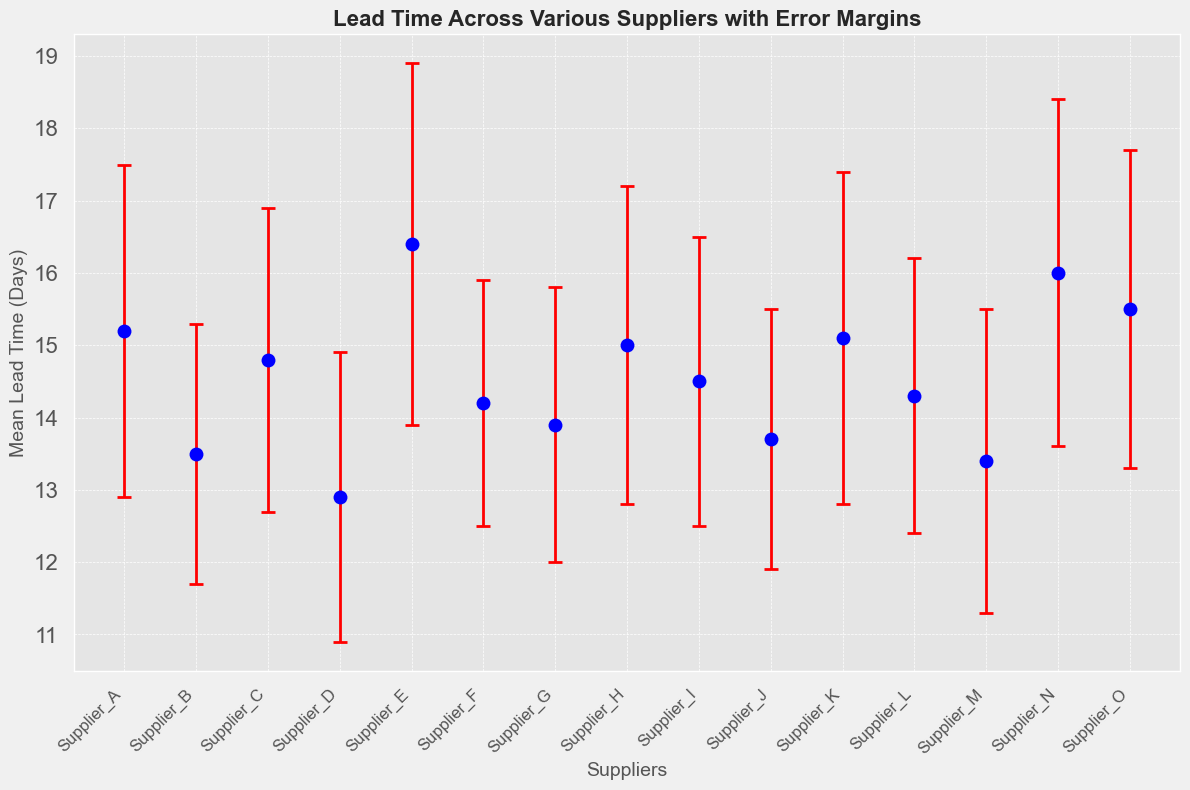Which supplier has the longest mean lead time? From the figure, Supplier E has the highest mean lead time.
Answer: Supplier E Which supplier has the shortest mean lead time? From the figure, Supplier D has the shortest mean lead time.
Answer: Supplier D How many suppliers have a mean lead time greater than 15 days? Suppliers A, E, H, K, N, and O have mean lead times greater than 15 days.
Answer: 6 How does Supplier F's mean lead time compare to Supplier M's? Supplier F has a mean lead time of 14.2 days, which is greater than Supplier M's mean lead time of 13.4 days.
Answer: Greater What is the difference between the highest and lowest mean lead times? The highest mean lead time is 16.4 days (Supplier E) and the lowest is 12.9 days (Supplier D). The difference is 16.4 - 12.9 = 3.5 days.
Answer: 3.5 days Which supplier has the largest error margin? From the figure, Supplier E has the largest error margin of 2.5 days.
Answer: Supplier E Compare the mean lead time and error margin of Supplier A and Supplier B. Supplier A has a mean lead time of 15.2 days with an error margin of 2.3 days, while Supplier B has a mean lead time of 13.5 days with an error margin of 1.8 days. Supplier A has both a higher mean lead time and a larger error margin than Supplier B.
Answer: Supplier A has higher mean lead time and larger error margin What is the average mean lead time for all suppliers? Sum of all mean lead times is 15.2 + 13.5 + 14.8 + 12.9 + 16.4 + 14.2 + 13.9 + 15.0 + 14.5 + 13.7 + 15.1 + 14.3 + 13.4 + 16.0 + 15.5 = 213.4 days. There are 15 suppliers, so the average mean lead time is 213.4 / 15 = 14.2 days.
Answer: 14.2 days Which suppliers have an error margin greater than 2 days? Suppliers A, C, E, H, K, N, and O have error margins greater than 2 days.
Answer: Suppliers A, C, E, H, K, N, and O How does the error margin of Supplier G compare to Supplier L? Supplier G has an error margin of 1.9 days and Supplier L has the same error margin of 1.9 days.
Answer: Equal 